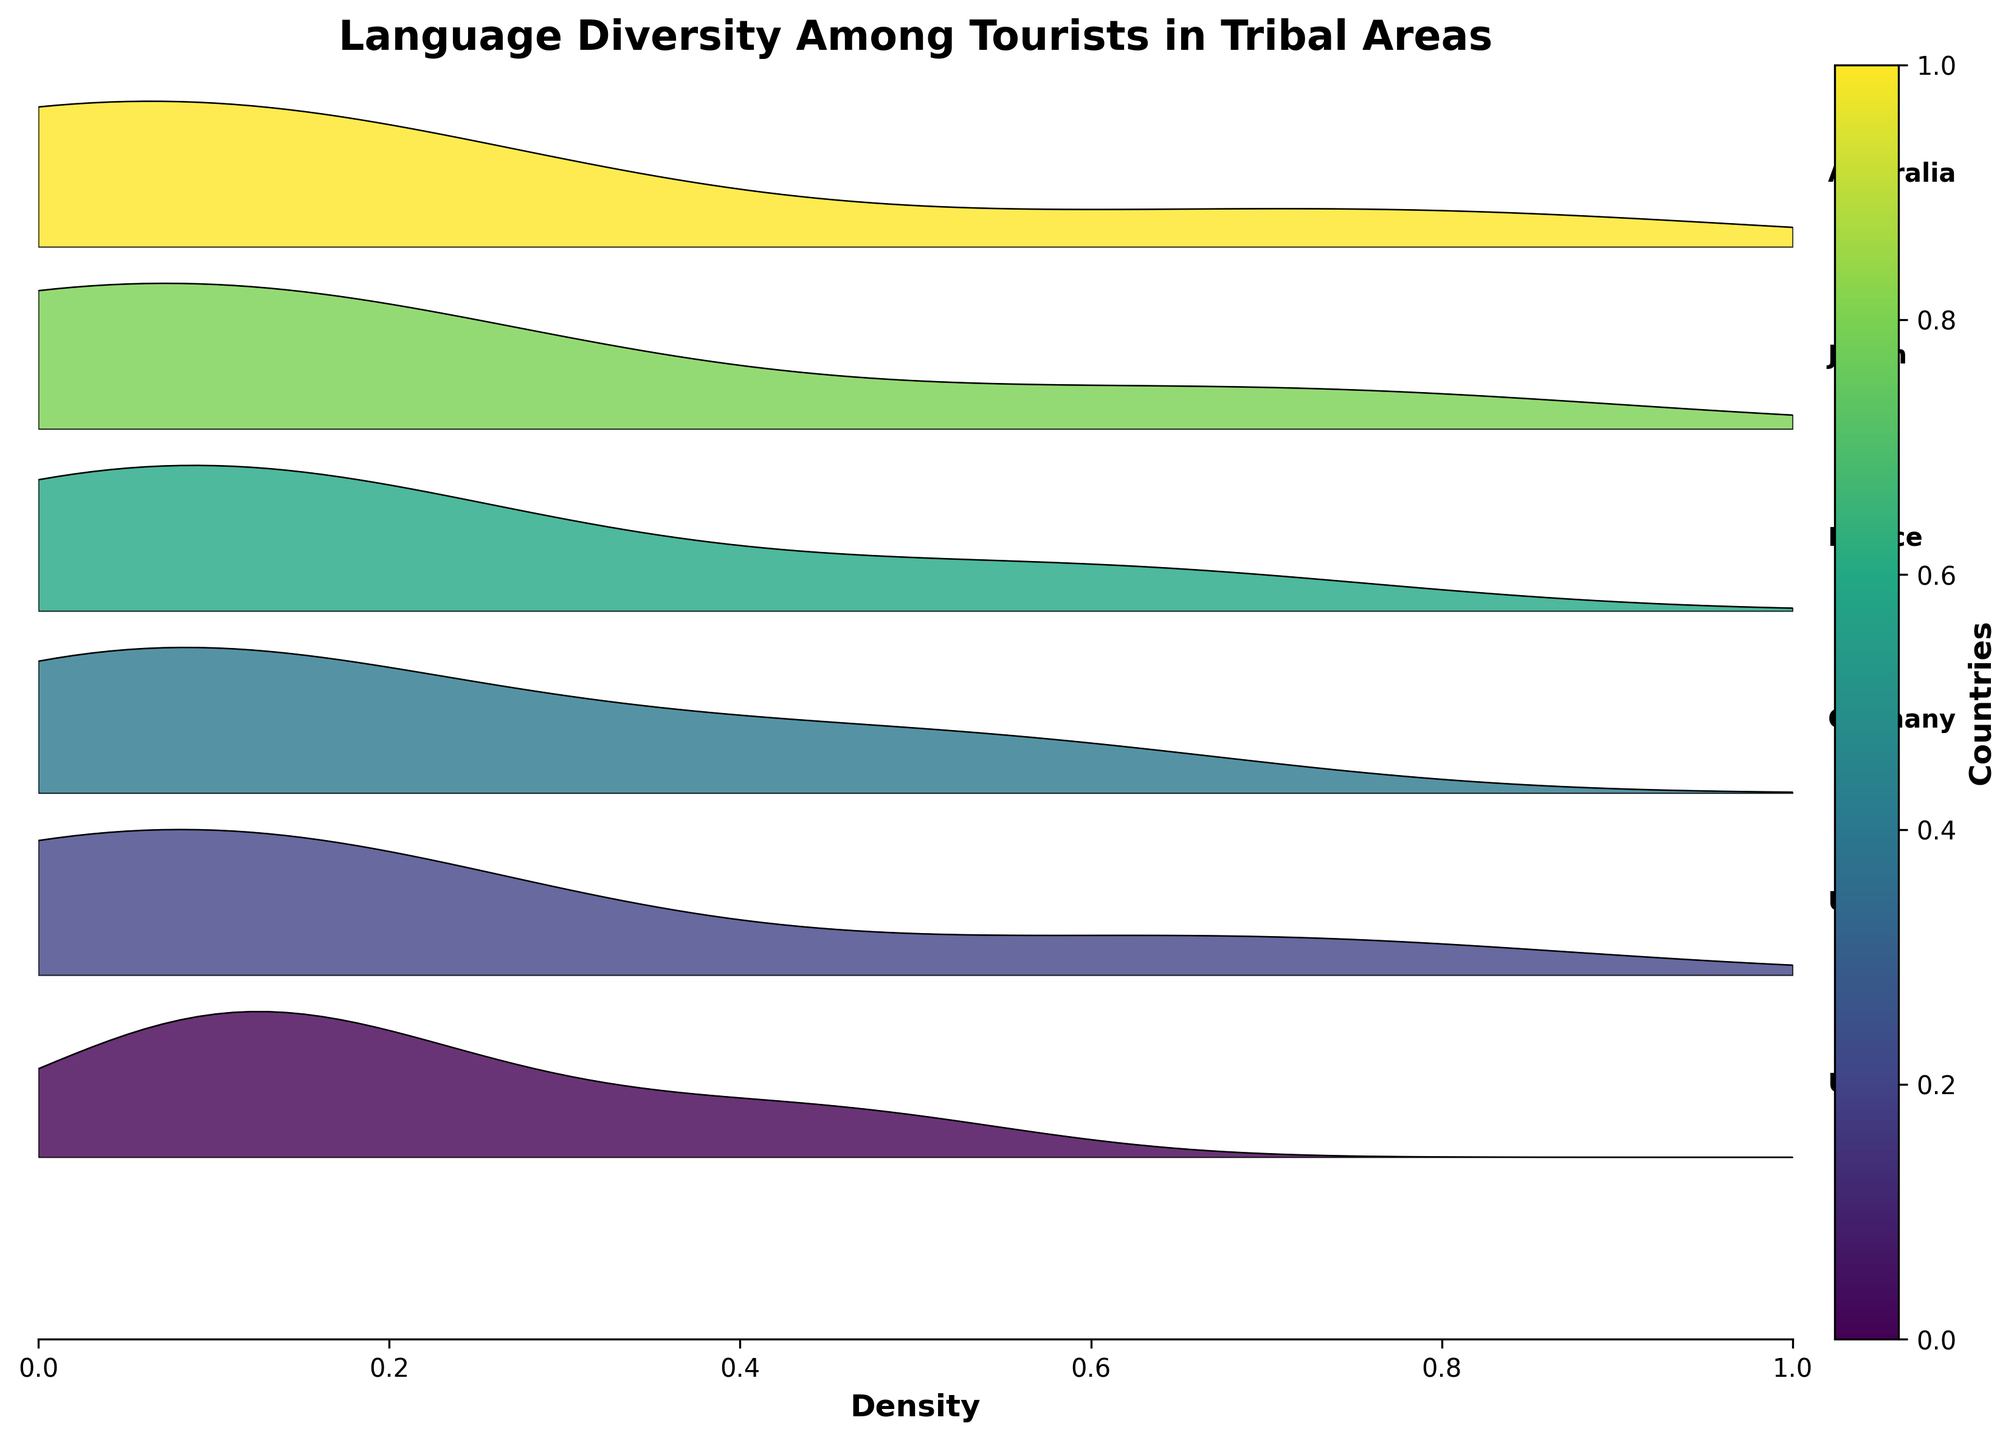what is the title of the plot? The title of the plot is usually located at the top center. In this case, it is "Language Diversity Among Tourists in Tribal Areas"
Answer: Language Diversity Among Tourists in Tribal Areas what is on the x-axis? The x-axis is labeled "Density," indicating it shows the density distribution of languages among tourists.
Answer: Density Which country has the highest density of tourists speaking English? By observing the ridgeline plots, the country with the highest peak in density for the English language is identified. For "English," the highest density peak is seen in the plot for Australia.
Answer: Australia how many countries are represented in this plot? By counting the number of countries listed on the vertical axis of the ridgeline plot, we find there are 6 countries.
Answer: 6 what is the dominant language among tourists from Germany? The dominant language for each country can be inferred by identifying the highest density peak. For Germany, "German" has the highest density.
Answer: German For which country is the density of tourists speaking Japanese the highest? By inspecting the plot for the language "Japanese," the ridgeline of Japan shows the highest peak. None of the other countries have a significant density for "Japanese."
Answer: Japan Compare the densities of French-speaking tourists from the USA and France. Which country has a higher density? Looking at the ridgeline plots for the language "French" in the USA and France. For the USA, the density is 0.12, whereas, for France, the density is 0.60. France has a higher density.
Answer: France what languages are spoken by tourists from the UK with densities greater than 0.05? Checking the densities for each language spoken by tourists from the UK: English (0.68), French (0.15), German (0.09). All these three languages have densities greater than 0.05.
Answer: English, French, German What is the least spoken language among tourists from Japan? To find the least spoken language, look for the smallest density value for tourists from Japan. "German" has the lowest density, with a value of 0.01.
Answer: German 